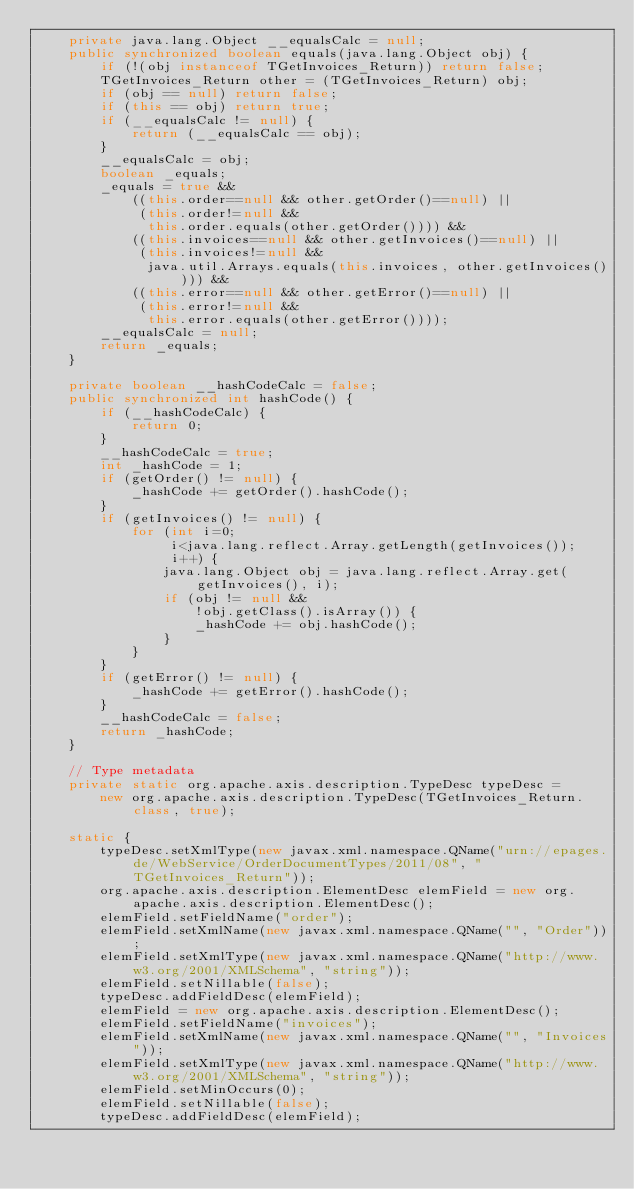Convert code to text. <code><loc_0><loc_0><loc_500><loc_500><_Java_>    private java.lang.Object __equalsCalc = null;
    public synchronized boolean equals(java.lang.Object obj) {
        if (!(obj instanceof TGetInvoices_Return)) return false;
        TGetInvoices_Return other = (TGetInvoices_Return) obj;
        if (obj == null) return false;
        if (this == obj) return true;
        if (__equalsCalc != null) {
            return (__equalsCalc == obj);
        }
        __equalsCalc = obj;
        boolean _equals;
        _equals = true && 
            ((this.order==null && other.getOrder()==null) || 
             (this.order!=null &&
              this.order.equals(other.getOrder()))) &&
            ((this.invoices==null && other.getInvoices()==null) || 
             (this.invoices!=null &&
              java.util.Arrays.equals(this.invoices, other.getInvoices()))) &&
            ((this.error==null && other.getError()==null) || 
             (this.error!=null &&
              this.error.equals(other.getError())));
        __equalsCalc = null;
        return _equals;
    }

    private boolean __hashCodeCalc = false;
    public synchronized int hashCode() {
        if (__hashCodeCalc) {
            return 0;
        }
        __hashCodeCalc = true;
        int _hashCode = 1;
        if (getOrder() != null) {
            _hashCode += getOrder().hashCode();
        }
        if (getInvoices() != null) {
            for (int i=0;
                 i<java.lang.reflect.Array.getLength(getInvoices());
                 i++) {
                java.lang.Object obj = java.lang.reflect.Array.get(getInvoices(), i);
                if (obj != null &&
                    !obj.getClass().isArray()) {
                    _hashCode += obj.hashCode();
                }
            }
        }
        if (getError() != null) {
            _hashCode += getError().hashCode();
        }
        __hashCodeCalc = false;
        return _hashCode;
    }

    // Type metadata
    private static org.apache.axis.description.TypeDesc typeDesc =
        new org.apache.axis.description.TypeDesc(TGetInvoices_Return.class, true);

    static {
        typeDesc.setXmlType(new javax.xml.namespace.QName("urn://epages.de/WebService/OrderDocumentTypes/2011/08", "TGetInvoices_Return"));
        org.apache.axis.description.ElementDesc elemField = new org.apache.axis.description.ElementDesc();
        elemField.setFieldName("order");
        elemField.setXmlName(new javax.xml.namespace.QName("", "Order"));
        elemField.setXmlType(new javax.xml.namespace.QName("http://www.w3.org/2001/XMLSchema", "string"));
        elemField.setNillable(false);
        typeDesc.addFieldDesc(elemField);
        elemField = new org.apache.axis.description.ElementDesc();
        elemField.setFieldName("invoices");
        elemField.setXmlName(new javax.xml.namespace.QName("", "Invoices"));
        elemField.setXmlType(new javax.xml.namespace.QName("http://www.w3.org/2001/XMLSchema", "string"));
        elemField.setMinOccurs(0);
        elemField.setNillable(false);
        typeDesc.addFieldDesc(elemField);</code> 